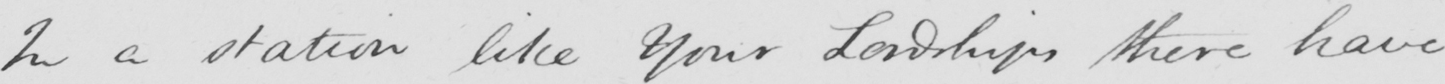What is written in this line of handwriting? In a station like Your Lordships there have 